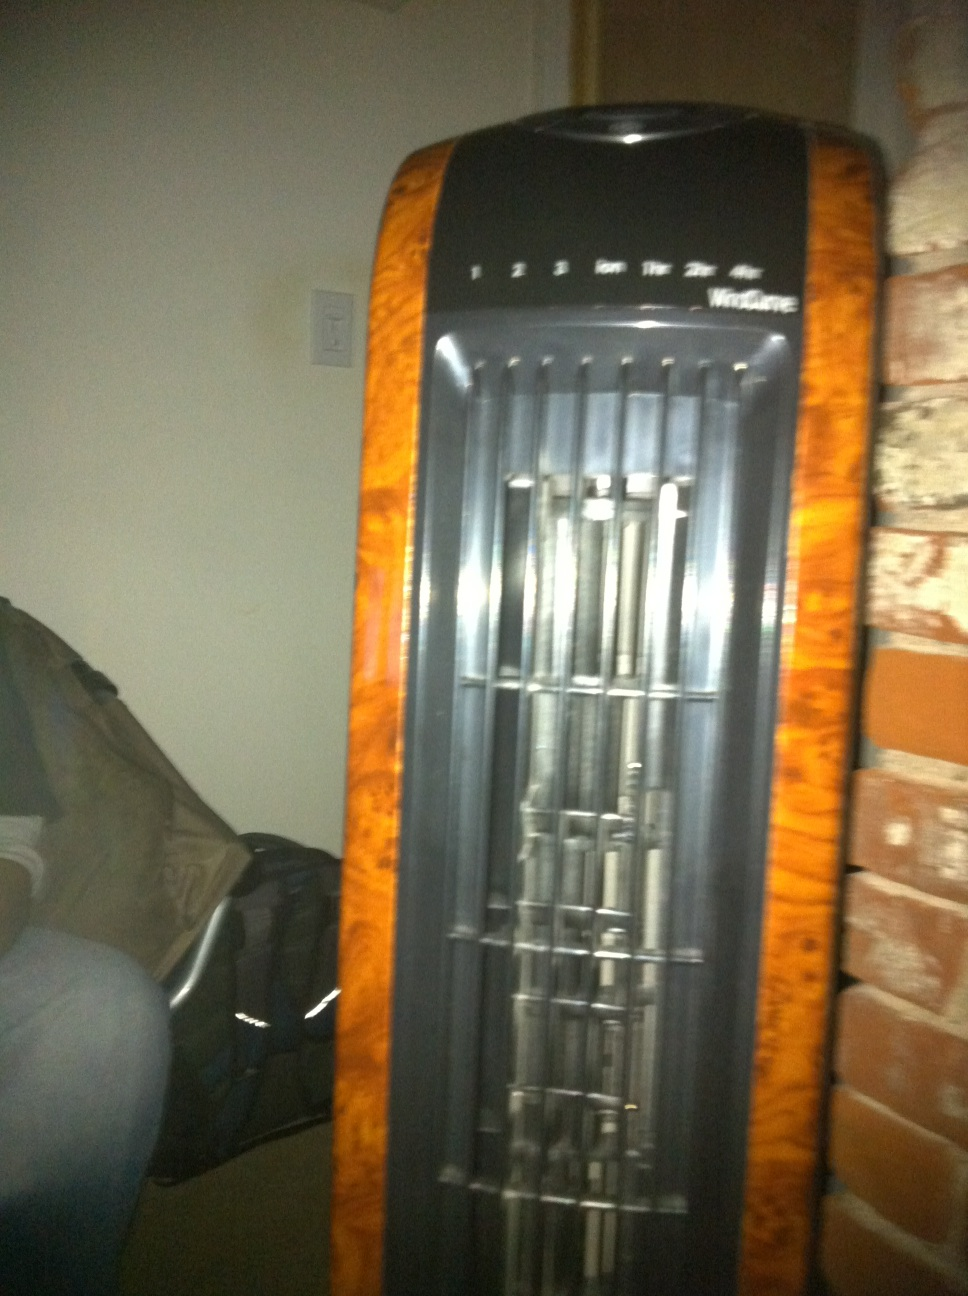What is the significance of this fan in a home setting? Fans like the one in the image serve as essential appliances in a home setting, especially in warmer climates or during the summer months. They provide necessary air circulation, which can help make the environment more comfortable and reduce dependency on air conditioning. Additionally, fans can help distribute air more evenly throughout a space, contributing to better indoor air quality. 